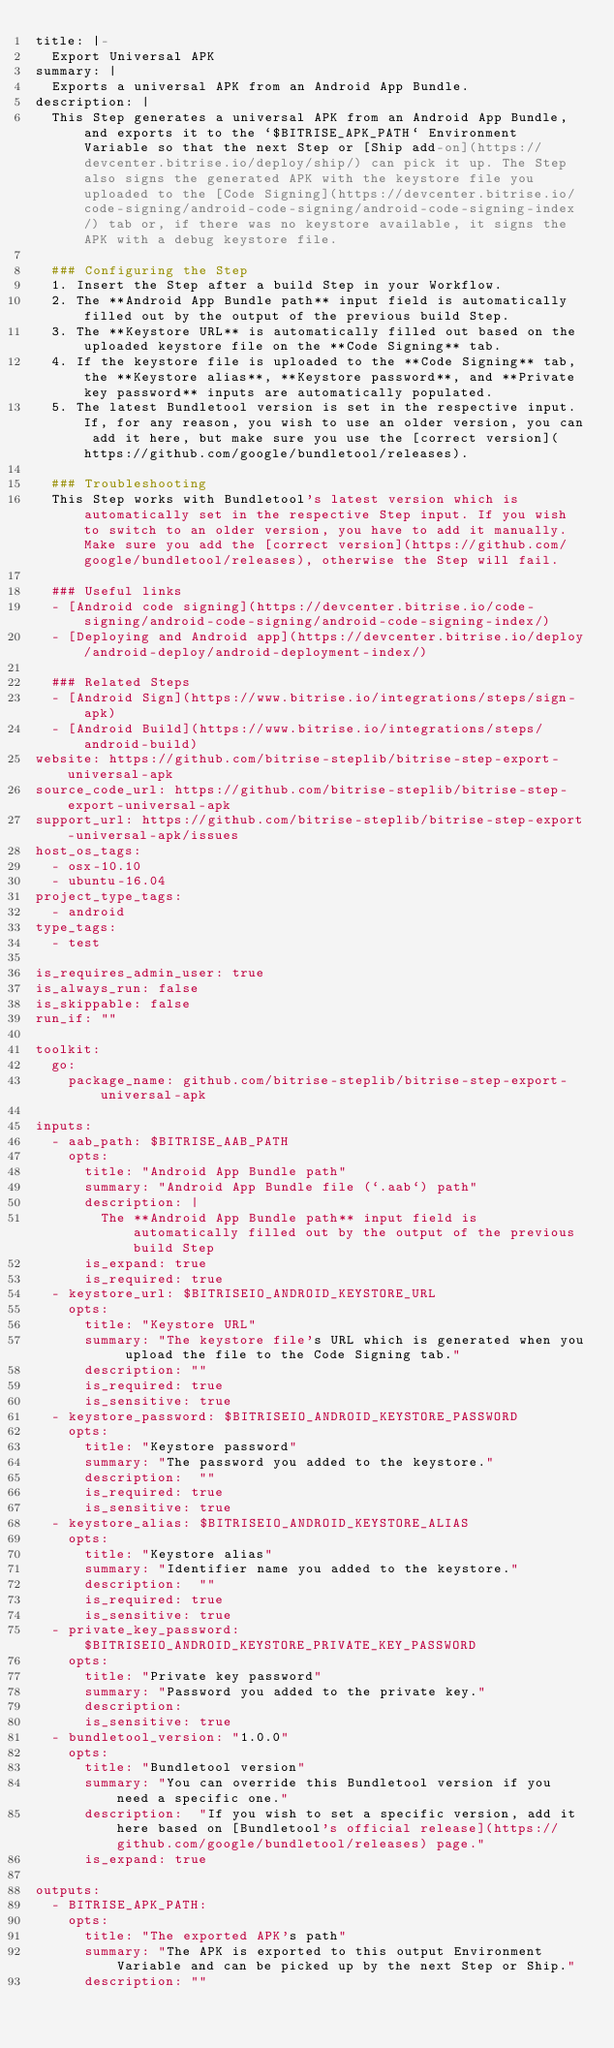<code> <loc_0><loc_0><loc_500><loc_500><_YAML_>title: |-
  Export Universal APK
summary: |
  Exports a universal APK from an Android App Bundle.
description: |
  This Step generates a universal APK from an Android App Bundle, and exports it to the `$BITRISE_APK_PATH` Environment Variable so that the next Step or [Ship add-on](https://devcenter.bitrise.io/deploy/ship/) can pick it up. The Step also signs the generated APK with the keystore file you uploaded to the [Code Signing](https://devcenter.bitrise.io/code-signing/android-code-signing/android-code-signing-index/) tab or, if there was no keystore available, it signs the APK with a debug keystore file.

  ### Configuring the Step
  1. Insert the Step after a build Step in your Workflow.
  2. The **Android App Bundle path** input field is automatically filled out by the output of the previous build Step.
  3. The **Keystore URL** is automatically filled out based on the uploaded keystore file on the **Code Signing** tab.
  4. If the keystore file is uploaded to the **Code Signing** tab, the **Keystore alias**, **Keystore password**, and **Private key password** inputs are automatically populated.
  5. The latest Bundletool version is set in the respective input. If, for any reason, you wish to use an older version, you can add it here, but make sure you use the [correct version](https://github.com/google/bundletool/releases).

  ### Troubleshooting
  This Step works with Bundletool's latest version which is automatically set in the respective Step input. If you wish to switch to an older version, you have to add it manually. Make sure you add the [correct version](https://github.com/google/bundletool/releases), otherwise the Step will fail.

  ### Useful links
  - [Android code signing](https://devcenter.bitrise.io/code-signing/android-code-signing/android-code-signing-index/)
  - [Deploying and Android app](https://devcenter.bitrise.io/deploy/android-deploy/android-deployment-index/)

  ### Related Steps
  - [Android Sign](https://www.bitrise.io/integrations/steps/sign-apk)
  - [Android Build](https://www.bitrise.io/integrations/steps/android-build)
website: https://github.com/bitrise-steplib/bitrise-step-export-universal-apk
source_code_url: https://github.com/bitrise-steplib/bitrise-step-export-universal-apk
support_url: https://github.com/bitrise-steplib/bitrise-step-export-universal-apk/issues
host_os_tags:
  - osx-10.10
  - ubuntu-16.04
project_type_tags:
  - android
type_tags:
  - test

is_requires_admin_user: true
is_always_run: false
is_skippable: false
run_if: ""

toolkit:
  go:
    package_name: github.com/bitrise-steplib/bitrise-step-export-universal-apk

inputs:
  - aab_path: $BITRISE_AAB_PATH
    opts:
      title: "Android App Bundle path"
      summary: "Android App Bundle file (`.aab`) path"
      description: |
        The **Android App Bundle path** input field is automatically filled out by the output of the previous build Step
      is_expand: true
      is_required: true
  - keystore_url: $BITRISEIO_ANDROID_KEYSTORE_URL
    opts:
      title: "Keystore URL"
      summary: "The keystore file's URL which is generated when you upload the file to the Code Signing tab."
      description: ""
      is_required: true
      is_sensitive: true
  - keystore_password: $BITRISEIO_ANDROID_KEYSTORE_PASSWORD
    opts:
      title: "Keystore password"
      summary: "The password you added to the keystore."
      description:  ""
      is_required: true
      is_sensitive: true
  - keystore_alias: $BITRISEIO_ANDROID_KEYSTORE_ALIAS
    opts:
      title: "Keystore alias"
      summary: "Identifier name you added to the keystore."
      description:  ""
      is_required: true
      is_sensitive: true
  - private_key_password: $BITRISEIO_ANDROID_KEYSTORE_PRIVATE_KEY_PASSWORD
    opts:
      title: "Private key password"
      summary: "Password you added to the private key."
      description:
      is_sensitive: true
  - bundletool_version: "1.0.0"
    opts:
      title: "Bundletool version"
      summary: "You can override this Bundletool version if you need a specific one."
      description:  "If you wish to set a specific version, add it here based on [Bundletool's official release](https://github.com/google/bundletool/releases) page."
      is_expand: true

outputs:
  - BITRISE_APK_PATH:
    opts:
      title: "The exported APK's path"
      summary: "The APK is exported to this output Environment Variable and can be picked up by the next Step or Ship."
      description: ""
       
</code> 